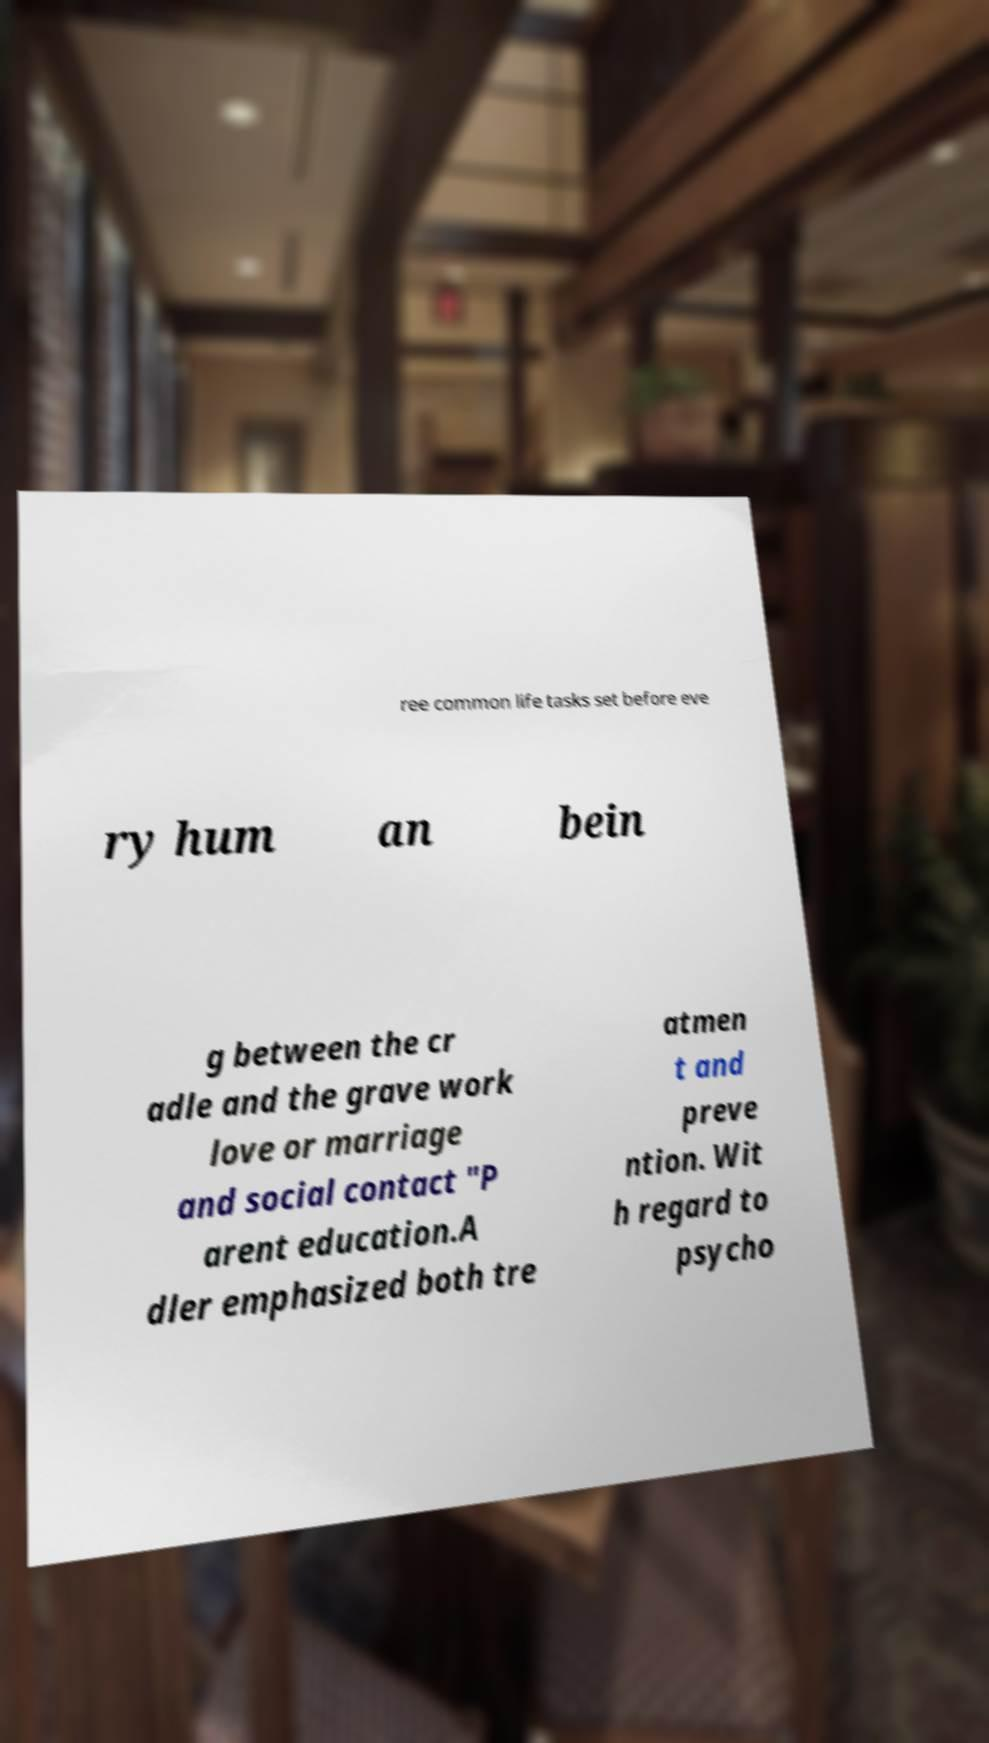Please read and relay the text visible in this image. What does it say? ree common life tasks set before eve ry hum an bein g between the cr adle and the grave work love or marriage and social contact "P arent education.A dler emphasized both tre atmen t and preve ntion. Wit h regard to psycho 